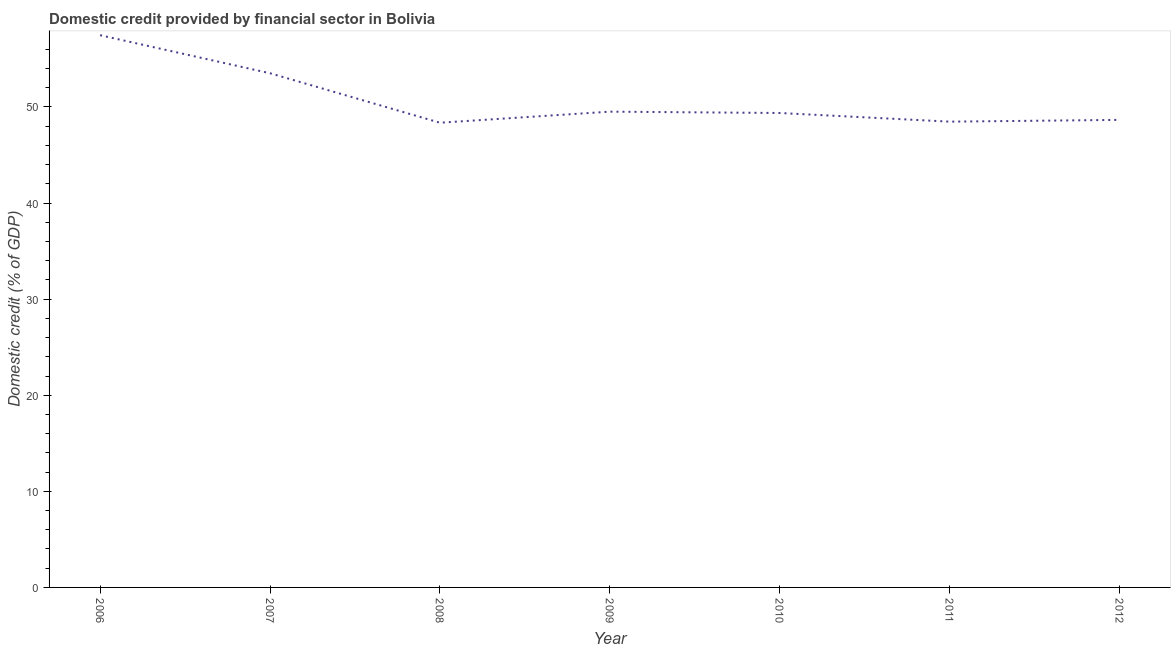What is the domestic credit provided by financial sector in 2010?
Your answer should be very brief. 49.37. Across all years, what is the maximum domestic credit provided by financial sector?
Give a very brief answer. 57.47. Across all years, what is the minimum domestic credit provided by financial sector?
Your answer should be very brief. 48.36. In which year was the domestic credit provided by financial sector maximum?
Your answer should be compact. 2006. In which year was the domestic credit provided by financial sector minimum?
Offer a terse response. 2008. What is the sum of the domestic credit provided by financial sector?
Provide a short and direct response. 355.34. What is the difference between the domestic credit provided by financial sector in 2006 and 2009?
Your response must be concise. 7.96. What is the average domestic credit provided by financial sector per year?
Offer a very short reply. 50.76. What is the median domestic credit provided by financial sector?
Your answer should be very brief. 49.37. Do a majority of the years between 2009 and 2007 (inclusive) have domestic credit provided by financial sector greater than 34 %?
Your answer should be compact. No. What is the ratio of the domestic credit provided by financial sector in 2006 to that in 2010?
Your answer should be very brief. 1.16. Is the domestic credit provided by financial sector in 2007 less than that in 2008?
Your answer should be compact. No. What is the difference between the highest and the second highest domestic credit provided by financial sector?
Offer a very short reply. 3.96. Is the sum of the domestic credit provided by financial sector in 2006 and 2012 greater than the maximum domestic credit provided by financial sector across all years?
Keep it short and to the point. Yes. What is the difference between the highest and the lowest domestic credit provided by financial sector?
Your answer should be very brief. 9.11. How many lines are there?
Give a very brief answer. 1. Are the values on the major ticks of Y-axis written in scientific E-notation?
Make the answer very short. No. Does the graph contain grids?
Give a very brief answer. No. What is the title of the graph?
Provide a succinct answer. Domestic credit provided by financial sector in Bolivia. What is the label or title of the X-axis?
Your response must be concise. Year. What is the label or title of the Y-axis?
Ensure brevity in your answer.  Domestic credit (% of GDP). What is the Domestic credit (% of GDP) in 2006?
Provide a succinct answer. 57.47. What is the Domestic credit (% of GDP) in 2007?
Your answer should be very brief. 53.51. What is the Domestic credit (% of GDP) in 2008?
Offer a terse response. 48.36. What is the Domestic credit (% of GDP) in 2009?
Keep it short and to the point. 49.51. What is the Domestic credit (% of GDP) in 2010?
Your answer should be very brief. 49.37. What is the Domestic credit (% of GDP) in 2011?
Offer a terse response. 48.47. What is the Domestic credit (% of GDP) of 2012?
Offer a very short reply. 48.65. What is the difference between the Domestic credit (% of GDP) in 2006 and 2007?
Ensure brevity in your answer.  3.96. What is the difference between the Domestic credit (% of GDP) in 2006 and 2008?
Offer a very short reply. 9.11. What is the difference between the Domestic credit (% of GDP) in 2006 and 2009?
Your answer should be very brief. 7.96. What is the difference between the Domestic credit (% of GDP) in 2006 and 2010?
Offer a terse response. 8.1. What is the difference between the Domestic credit (% of GDP) in 2006 and 2011?
Ensure brevity in your answer.  9. What is the difference between the Domestic credit (% of GDP) in 2006 and 2012?
Give a very brief answer. 8.81. What is the difference between the Domestic credit (% of GDP) in 2007 and 2008?
Your answer should be compact. 5.15. What is the difference between the Domestic credit (% of GDP) in 2007 and 2009?
Your answer should be very brief. 4. What is the difference between the Domestic credit (% of GDP) in 2007 and 2010?
Your answer should be compact. 4.14. What is the difference between the Domestic credit (% of GDP) in 2007 and 2011?
Ensure brevity in your answer.  5.04. What is the difference between the Domestic credit (% of GDP) in 2007 and 2012?
Keep it short and to the point. 4.85. What is the difference between the Domestic credit (% of GDP) in 2008 and 2009?
Give a very brief answer. -1.15. What is the difference between the Domestic credit (% of GDP) in 2008 and 2010?
Provide a succinct answer. -1.01. What is the difference between the Domestic credit (% of GDP) in 2008 and 2011?
Offer a terse response. -0.11. What is the difference between the Domestic credit (% of GDP) in 2008 and 2012?
Offer a very short reply. -0.3. What is the difference between the Domestic credit (% of GDP) in 2009 and 2010?
Make the answer very short. 0.14. What is the difference between the Domestic credit (% of GDP) in 2009 and 2011?
Your answer should be very brief. 1.04. What is the difference between the Domestic credit (% of GDP) in 2009 and 2012?
Make the answer very short. 0.86. What is the difference between the Domestic credit (% of GDP) in 2010 and 2011?
Offer a terse response. 0.9. What is the difference between the Domestic credit (% of GDP) in 2010 and 2012?
Provide a short and direct response. 0.72. What is the difference between the Domestic credit (% of GDP) in 2011 and 2012?
Ensure brevity in your answer.  -0.18. What is the ratio of the Domestic credit (% of GDP) in 2006 to that in 2007?
Make the answer very short. 1.07. What is the ratio of the Domestic credit (% of GDP) in 2006 to that in 2008?
Ensure brevity in your answer.  1.19. What is the ratio of the Domestic credit (% of GDP) in 2006 to that in 2009?
Provide a short and direct response. 1.16. What is the ratio of the Domestic credit (% of GDP) in 2006 to that in 2010?
Your response must be concise. 1.16. What is the ratio of the Domestic credit (% of GDP) in 2006 to that in 2011?
Offer a very short reply. 1.19. What is the ratio of the Domestic credit (% of GDP) in 2006 to that in 2012?
Offer a terse response. 1.18. What is the ratio of the Domestic credit (% of GDP) in 2007 to that in 2008?
Give a very brief answer. 1.11. What is the ratio of the Domestic credit (% of GDP) in 2007 to that in 2009?
Provide a succinct answer. 1.08. What is the ratio of the Domestic credit (% of GDP) in 2007 to that in 2010?
Offer a very short reply. 1.08. What is the ratio of the Domestic credit (% of GDP) in 2007 to that in 2011?
Your answer should be compact. 1.1. What is the ratio of the Domestic credit (% of GDP) in 2008 to that in 2010?
Your answer should be compact. 0.98. What is the ratio of the Domestic credit (% of GDP) in 2008 to that in 2012?
Offer a terse response. 0.99. What is the ratio of the Domestic credit (% of GDP) in 2009 to that in 2011?
Your answer should be compact. 1.02. What is the ratio of the Domestic credit (% of GDP) in 2010 to that in 2012?
Make the answer very short. 1.01. What is the ratio of the Domestic credit (% of GDP) in 2011 to that in 2012?
Your answer should be compact. 1. 